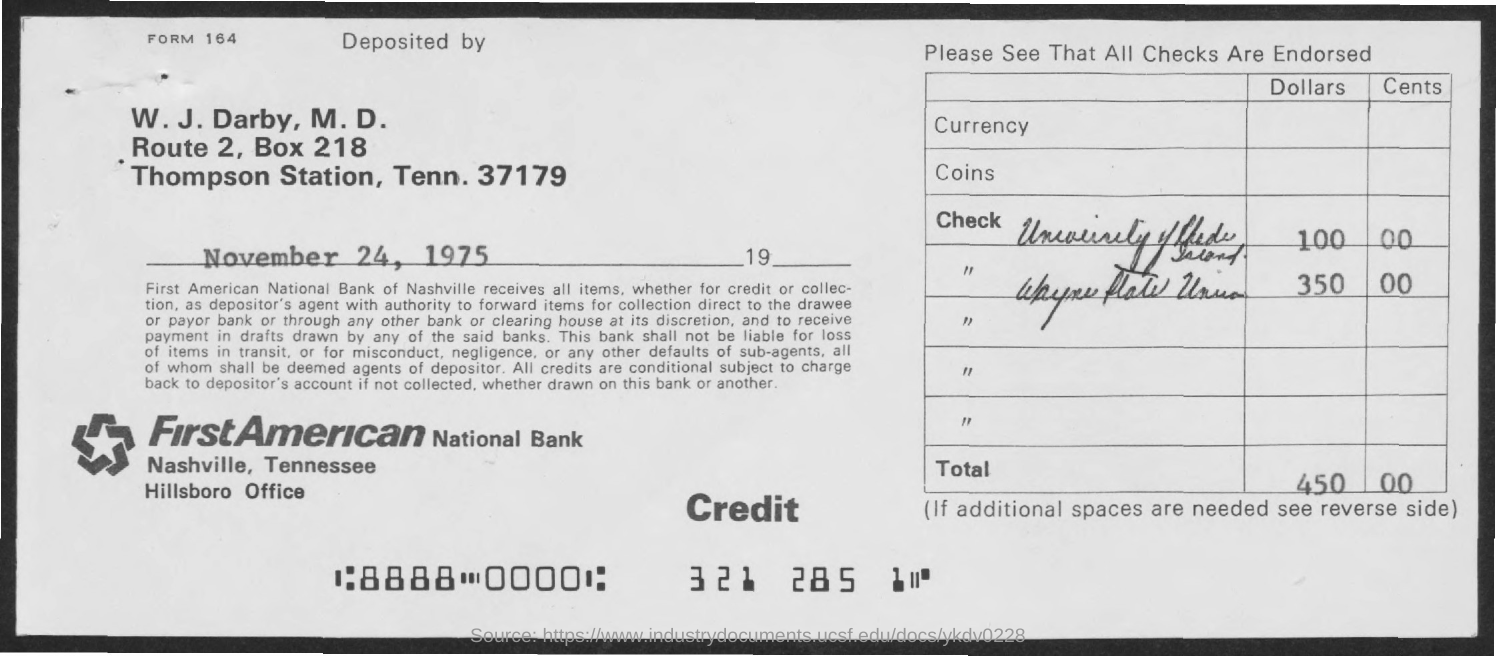Highlight a few significant elements in this photo. The total amount of deposit is 450,000. First American National Bank is the name of the bank. The address of the First American National Bank in Nashville, Tennessee is located at the Hillsbore Office. What is the form number?" is a question that is being asked. The form number being referred to is 164. The date of deposit is November 24, 1975. 